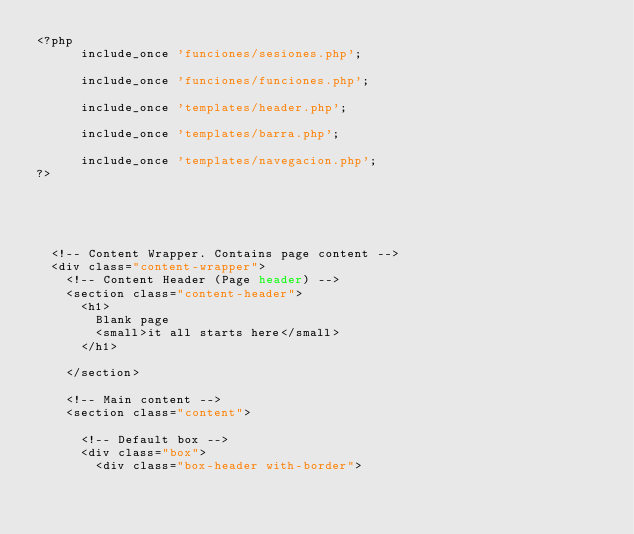Convert code to text. <code><loc_0><loc_0><loc_500><loc_500><_PHP_><?php
      include_once 'funciones/sesiones.php';

      include_once 'funciones/funciones.php';

      include_once 'templates/header.php';

      include_once 'templates/barra.php';

      include_once 'templates/navegacion.php';
?>





  <!-- Content Wrapper. Contains page content -->
  <div class="content-wrapper">
    <!-- Content Header (Page header) -->
    <section class="content-header">
      <h1>
        Blank page
        <small>it all starts here</small>
      </h1>
      
    </section>

    <!-- Main content -->
    <section class="content">

      <!-- Default box -->
      <div class="box">
        <div class="box-header with-border"></code> 